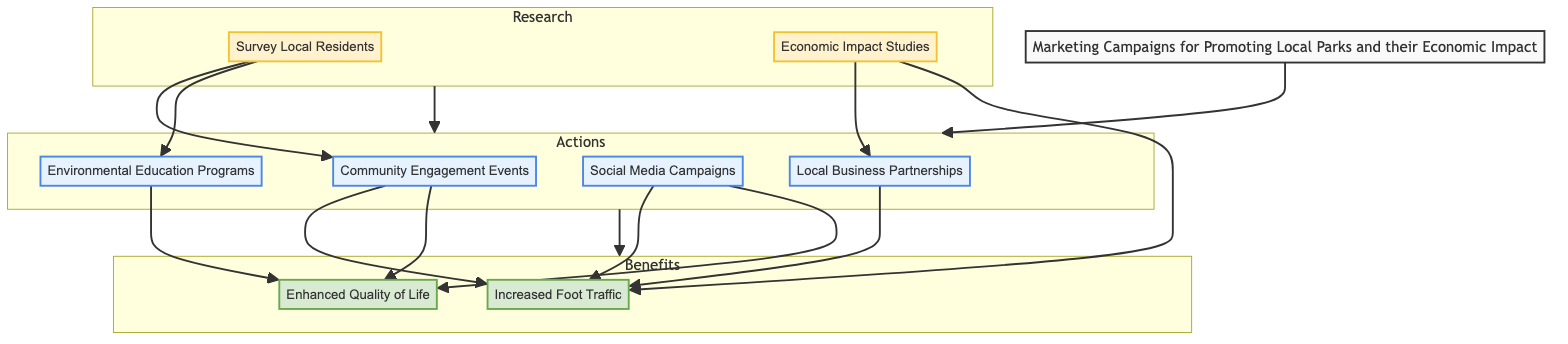What types of nodes are present in the diagram? The diagram includes three types of nodes: action, research, and benefit. Each type has distinct roles within the marketing campaign framework.
Answer: action, research, benefit How many action nodes are there? Counting the action nodes, there are four distinct actions outlined in the diagram: Community Engagement Events, Local Business Partnerships, Social Media Campaigns, and Environmental Education Programs.
Answer: 4 Which action node leads to Enhanced Quality of Life? The Enhanced Quality of Life node is reached through two action nodes: Community Engagement Events and Environmental Education Programs.
Answer: Community Engagement Events, Environmental Education Programs What does the Economic Impact Studies research lead to? The Economic Impact Studies research node directly influences the Local Business Partnerships action node and also leads to the Increased Foot Traffic benefit node; thus, it supports both actions and benefits in the diagram.
Answer: Local Business Partnerships, Increased Foot Traffic Which benefit node is associated with Increased Foot Traffic? The Increased Foot Traffic benefit node is associated with several action nodes, including Community Engagement Events, Local Business Partnerships, Social Media Campaigns, and Economic Impact Studies.
Answer: Increased Foot Traffic How many edges are there from research nodes to action nodes? Analyzing the connections, there are three edges from the research nodes (Survey Local Residents, Economic Impact Studies) that lead to the action nodes, signifying the flow from research to action.
Answer: 3 Which action nodes are influenced by Survey Local Residents? Survey Local Residents influences two action nodes: Community Engagement Events and Environmental Education Programs, focusing on enhancing them based on community feedback.
Answer: Community Engagement Events, Environmental Education Programs What is the relationship between Environmental Education Programs and Enhanced Quality of Life? Environmental Education Programs directly contribute to the Enhanced Quality of Life benefit node, indicating that educational efforts improve community well-being and attract visitors.
Answer: Contributes What type of diagram is being presented? The presented diagram is a Bottom Up Flow Chart that illustrates the sequential process of marketing campaigns aimed at promoting local parks and their economic impact.
Answer: Bottom Up Flow Chart 